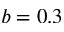Convert formula to latex. <formula><loc_0><loc_0><loc_500><loc_500>b = 0 . 3</formula> 